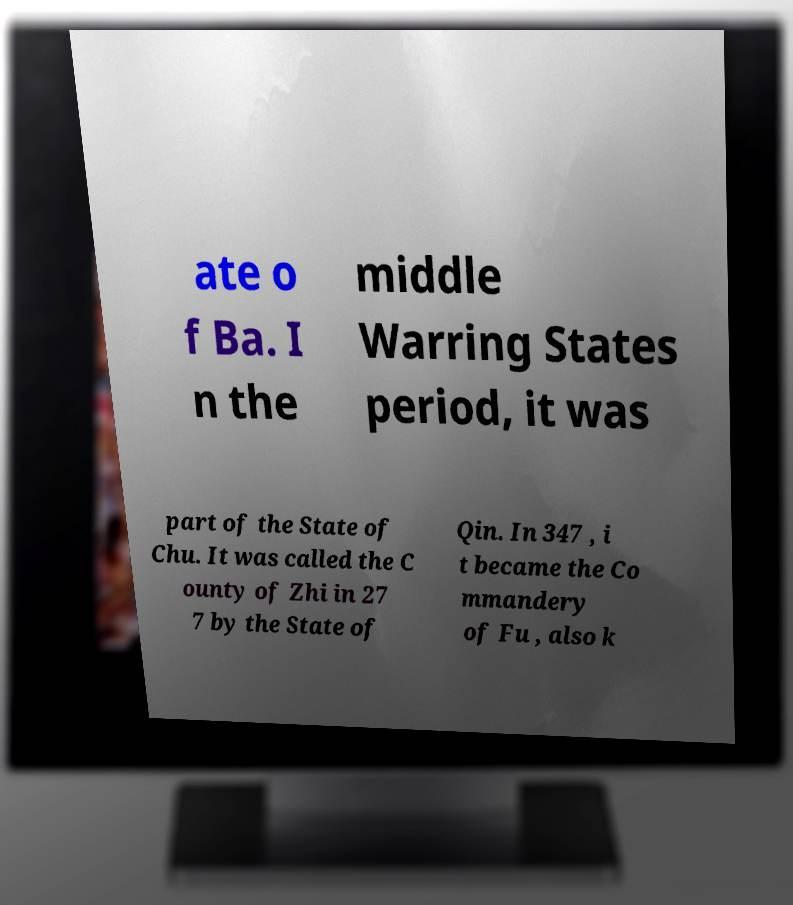What messages or text are displayed in this image? I need them in a readable, typed format. ate o f Ba. I n the middle Warring States period, it was part of the State of Chu. It was called the C ounty of Zhi in 27 7 by the State of Qin. In 347 , i t became the Co mmandery of Fu , also k 